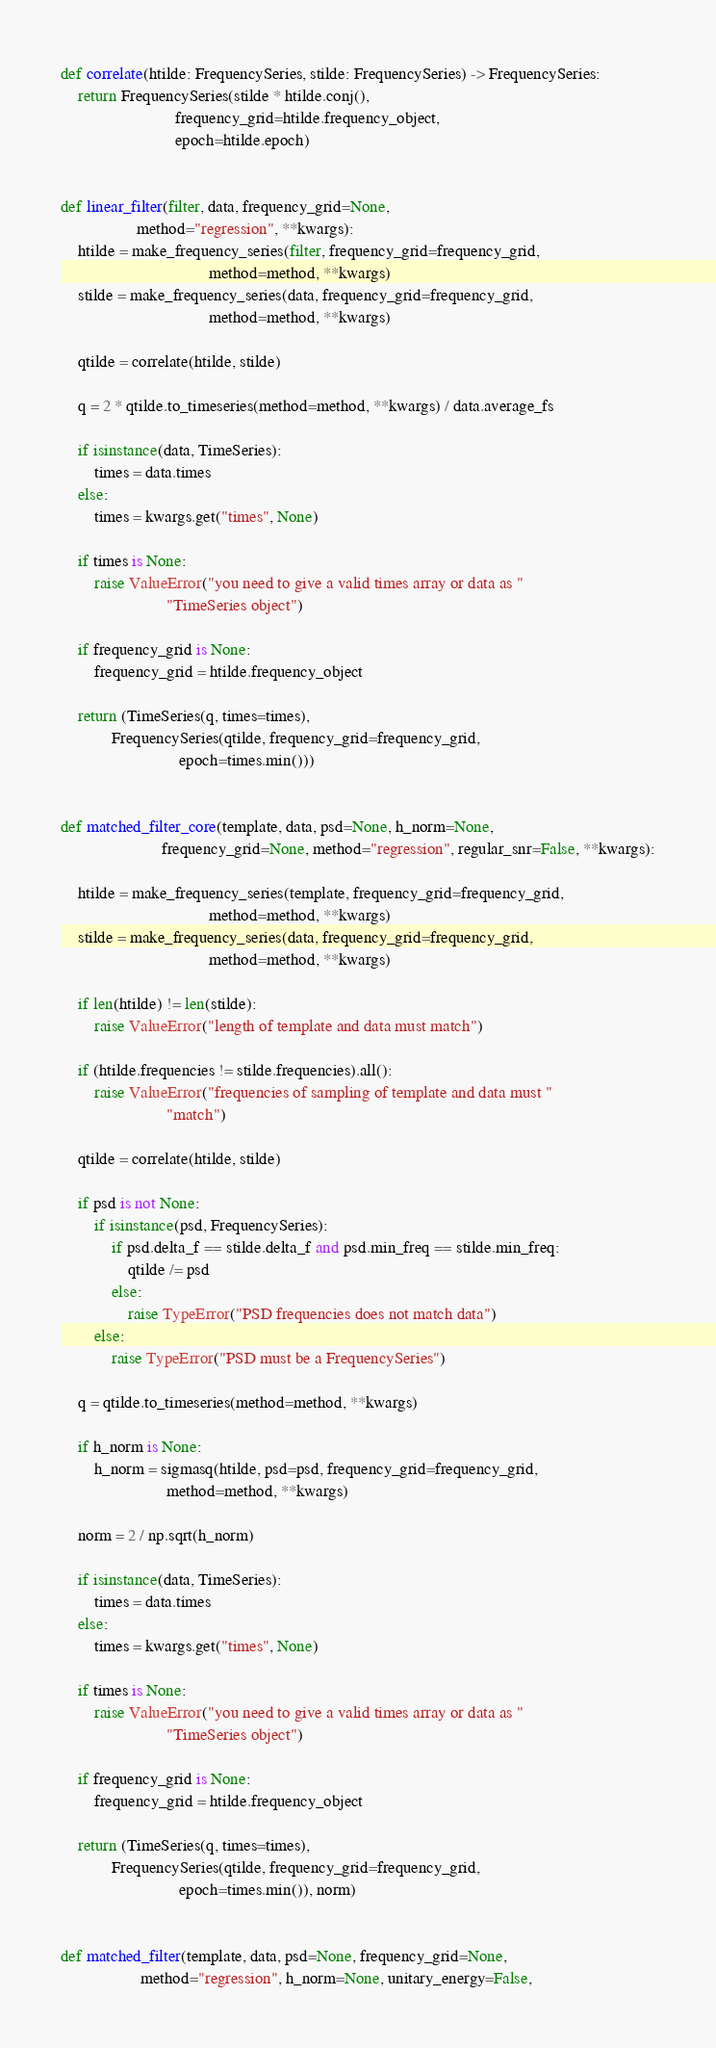Convert code to text. <code><loc_0><loc_0><loc_500><loc_500><_Python_>

def correlate(htilde: FrequencySeries, stilde: FrequencySeries) -> FrequencySeries:
    return FrequencySeries(stilde * htilde.conj(),
                           frequency_grid=htilde.frequency_object,
                           epoch=htilde.epoch)


def linear_filter(filter, data, frequency_grid=None,
                  method="regression", **kwargs):
    htilde = make_frequency_series(filter, frequency_grid=frequency_grid,
                                   method=method, **kwargs)
    stilde = make_frequency_series(data, frequency_grid=frequency_grid,
                                   method=method, **kwargs)

    qtilde = correlate(htilde, stilde)

    q = 2 * qtilde.to_timeseries(method=method, **kwargs) / data.average_fs

    if isinstance(data, TimeSeries):
        times = data.times
    else:
        times = kwargs.get("times", None)

    if times is None:
        raise ValueError("you need to give a valid times array or data as "
                         "TimeSeries object")

    if frequency_grid is None:
        frequency_grid = htilde.frequency_object

    return (TimeSeries(q, times=times),
            FrequencySeries(qtilde, frequency_grid=frequency_grid,
                            epoch=times.min()))


def matched_filter_core(template, data, psd=None, h_norm=None,
                        frequency_grid=None, method="regression", regular_snr=False, **kwargs):

    htilde = make_frequency_series(template, frequency_grid=frequency_grid,
                                   method=method, **kwargs)
    stilde = make_frequency_series(data, frequency_grid=frequency_grid,
                                   method=method, **kwargs)

    if len(htilde) != len(stilde):
        raise ValueError("length of template and data must match")

    if (htilde.frequencies != stilde.frequencies).all():
        raise ValueError("frequencies of sampling of template and data must "
                         "match")

    qtilde = correlate(htilde, stilde)

    if psd is not None:
        if isinstance(psd, FrequencySeries):
            if psd.delta_f == stilde.delta_f and psd.min_freq == stilde.min_freq:
                qtilde /= psd
            else:
                raise TypeError("PSD frequencies does not match data")
        else:
            raise TypeError("PSD must be a FrequencySeries")

    q = qtilde.to_timeseries(method=method, **kwargs)

    if h_norm is None:
        h_norm = sigmasq(htilde, psd=psd, frequency_grid=frequency_grid,
                         method=method, **kwargs)

    norm = 2 / np.sqrt(h_norm)

    if isinstance(data, TimeSeries):
        times = data.times
    else:
        times = kwargs.get("times", None)

    if times is None:
        raise ValueError("you need to give a valid times array or data as "
                         "TimeSeries object")

    if frequency_grid is None:
        frequency_grid = htilde.frequency_object

    return (TimeSeries(q, times=times),
            FrequencySeries(qtilde, frequency_grid=frequency_grid,
                            epoch=times.min()), norm)


def matched_filter(template, data, psd=None, frequency_grid=None,
                   method="regression", h_norm=None, unitary_energy=False,</code> 